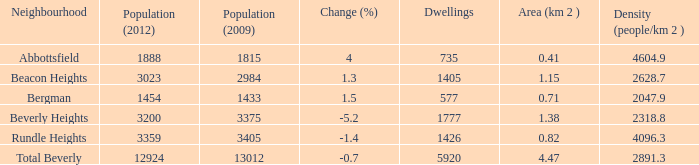What is the density of an area that is 1.38km and has a population more than 12924? 0.0. 